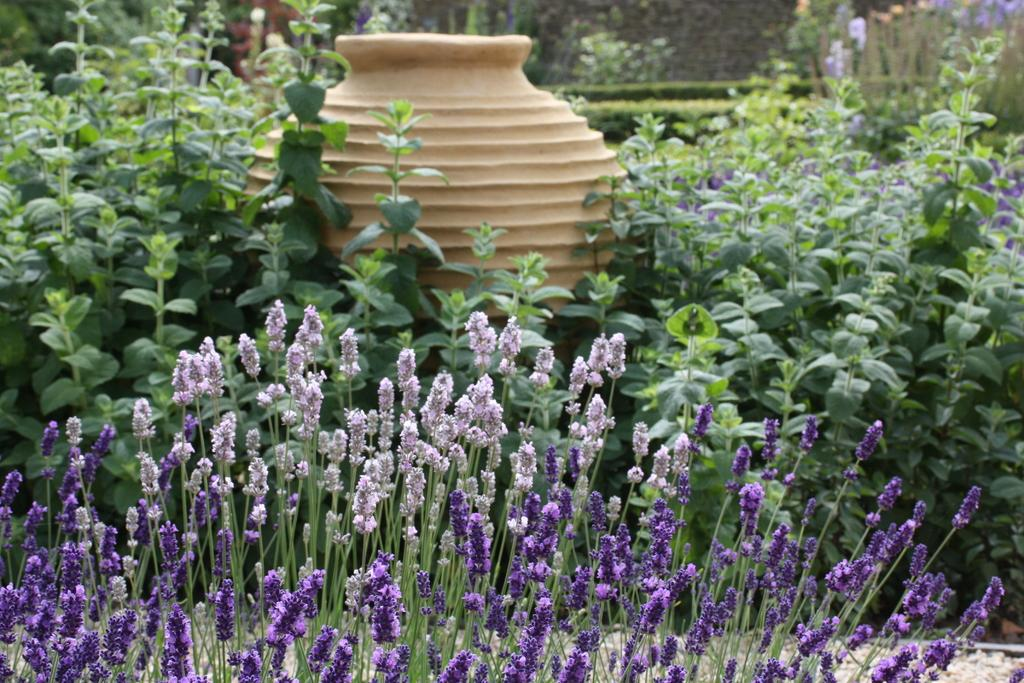What type of natural environment is depicted in the image? The image contains beautiful greenery. What colors are the flowers in the image? There are lavender and purple color flowers in the image. Can you describe the arrangement of the plants in the image? There is a pot in between the plants in the image. What type of sofa can be seen in the image? There is no sofa present in the image; it features beautiful greenery and flowers. What type of agreement is being made between the plants in the image? There is no agreement being made between the plants in the image; they are simply growing in the greenery. 